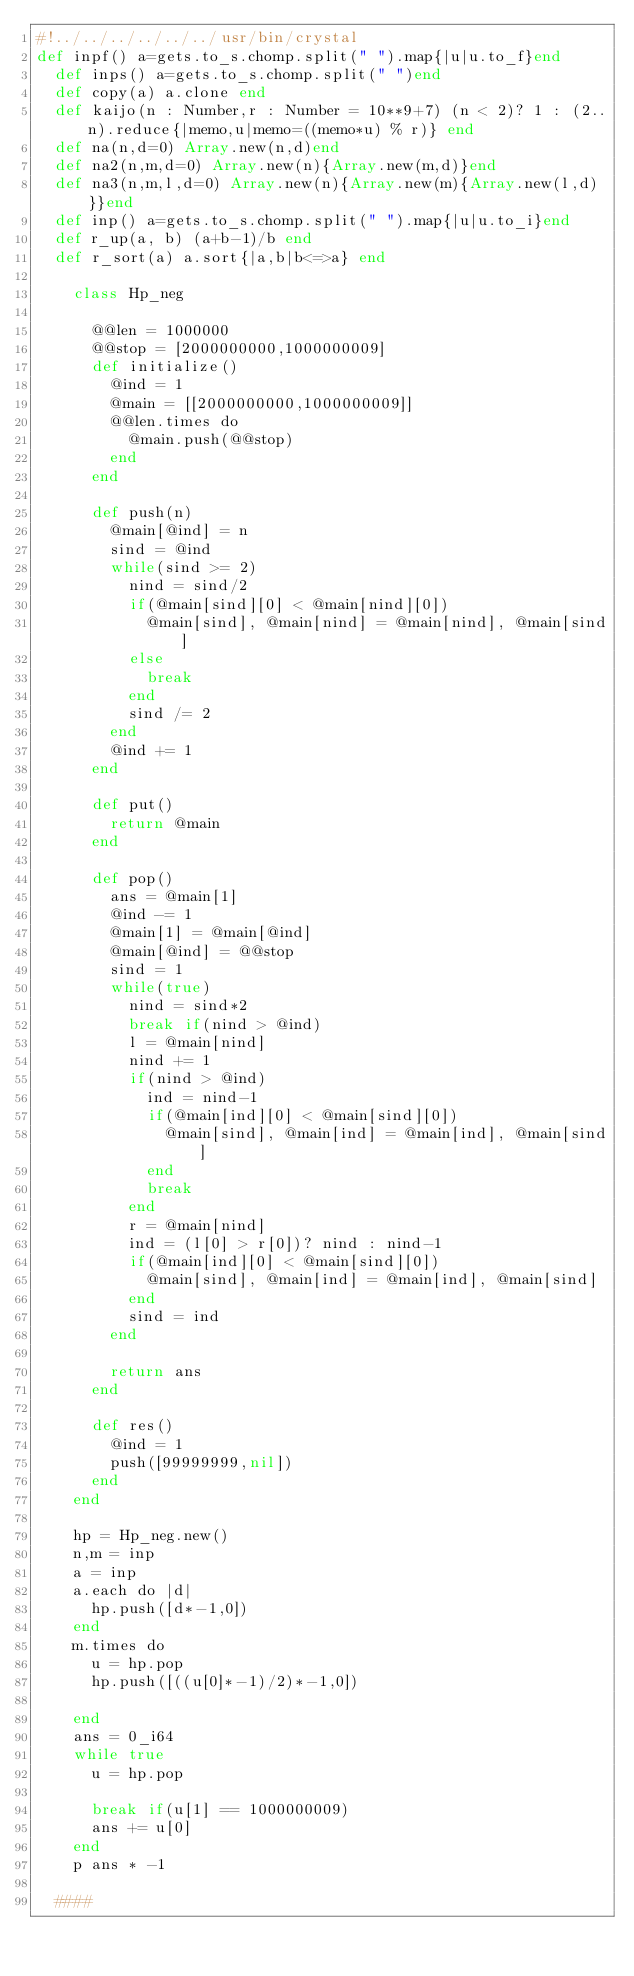Convert code to text. <code><loc_0><loc_0><loc_500><loc_500><_Crystal_>#!../../../../../../usr/bin/crystal
def inpf() a=gets.to_s.chomp.split(" ").map{|u|u.to_f}end
  def inps() a=gets.to_s.chomp.split(" ")end
  def copy(a) a.clone end
  def kaijo(n : Number,r : Number = 10**9+7) (n < 2)? 1 : (2..n).reduce{|memo,u|memo=((memo*u) % r)} end
  def na(n,d=0) Array.new(n,d)end
  def na2(n,m,d=0) Array.new(n){Array.new(m,d)}end
  def na3(n,m,l,d=0) Array.new(n){Array.new(m){Array.new(l,d)}}end
  def inp() a=gets.to_s.chomp.split(" ").map{|u|u.to_i}end
  def r_up(a, b) (a+b-1)/b end
  def r_sort(a) a.sort{|a,b|b<=>a} end

    class Hp_neg

      @@len = 1000000
      @@stop = [2000000000,1000000009]
      def initialize()
        @ind = 1
        @main = [[2000000000,1000000009]]
        @@len.times do 
          @main.push(@@stop)
        end
      end
    
      def push(n)
        @main[@ind] = n
        sind = @ind
        while(sind >= 2)
          nind = sind/2
          if(@main[sind][0] < @main[nind][0])
            @main[sind], @main[nind] = @main[nind], @main[sind]
          else
            break
          end
          sind /= 2
        end
        @ind += 1
      end
    
      def put()
        return @main
      end
    
      def pop()
        ans = @main[1]
        @ind -= 1
        @main[1] = @main[@ind]
        @main[@ind] = @@stop
        sind = 1
        while(true)
          nind = sind*2
          break if(nind > @ind)
          l = @main[nind]
          nind += 1
          if(nind > @ind)
            ind = nind-1
            if(@main[ind][0] < @main[sind][0])
              @main[sind], @main[ind] = @main[ind], @main[sind]
            end
            break
          end
          r = @main[nind]
          ind = (l[0] > r[0])? nind : nind-1
          if(@main[ind][0] < @main[sind][0])
            @main[sind], @main[ind] = @main[ind], @main[sind]
          end
          sind = ind
        end
    
        return ans
      end
    
      def res()
        @ind = 1
        push([99999999,nil])
      end
    end
    
    hp = Hp_neg.new()
    n,m = inp
    a = inp
    a.each do |d|
      hp.push([d*-1,0])
    end
    m.times do
      u = hp.pop
      hp.push([((u[0]*-1)/2)*-1,0])

    end
    ans = 0_i64
    while true
      u = hp.pop
    
      break if(u[1] == 1000000009)
      ans += u[0]
    end
    p ans * -1
    
  ####
  
  
  </code> 